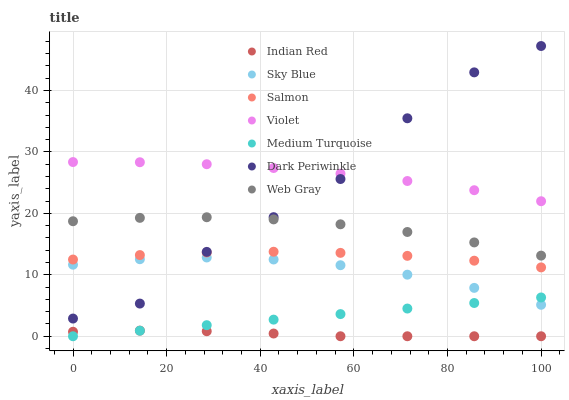Does Indian Red have the minimum area under the curve?
Answer yes or no. Yes. Does Violet have the maximum area under the curve?
Answer yes or no. Yes. Does Salmon have the minimum area under the curve?
Answer yes or no. No. Does Salmon have the maximum area under the curve?
Answer yes or no. No. Is Medium Turquoise the smoothest?
Answer yes or no. Yes. Is Dark Periwinkle the roughest?
Answer yes or no. Yes. Is Indian Red the smoothest?
Answer yes or no. No. Is Indian Red the roughest?
Answer yes or no. No. Does Indian Red have the lowest value?
Answer yes or no. Yes. Does Salmon have the lowest value?
Answer yes or no. No. Does Dark Periwinkle have the highest value?
Answer yes or no. Yes. Does Salmon have the highest value?
Answer yes or no. No. Is Sky Blue less than Violet?
Answer yes or no. Yes. Is Web Gray greater than Sky Blue?
Answer yes or no. Yes. Does Sky Blue intersect Dark Periwinkle?
Answer yes or no. Yes. Is Sky Blue less than Dark Periwinkle?
Answer yes or no. No. Is Sky Blue greater than Dark Periwinkle?
Answer yes or no. No. Does Sky Blue intersect Violet?
Answer yes or no. No. 